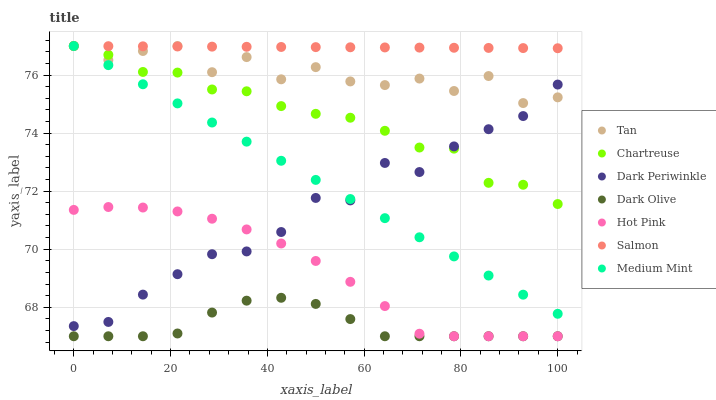Does Dark Olive have the minimum area under the curve?
Answer yes or no. Yes. Does Salmon have the maximum area under the curve?
Answer yes or no. Yes. Does Hot Pink have the minimum area under the curve?
Answer yes or no. No. Does Hot Pink have the maximum area under the curve?
Answer yes or no. No. Is Medium Mint the smoothest?
Answer yes or no. Yes. Is Tan the roughest?
Answer yes or no. Yes. Is Hot Pink the smoothest?
Answer yes or no. No. Is Hot Pink the roughest?
Answer yes or no. No. Does Hot Pink have the lowest value?
Answer yes or no. Yes. Does Salmon have the lowest value?
Answer yes or no. No. Does Tan have the highest value?
Answer yes or no. Yes. Does Hot Pink have the highest value?
Answer yes or no. No. Is Dark Olive less than Salmon?
Answer yes or no. Yes. Is Tan greater than Dark Olive?
Answer yes or no. Yes. Does Tan intersect Medium Mint?
Answer yes or no. Yes. Is Tan less than Medium Mint?
Answer yes or no. No. Is Tan greater than Medium Mint?
Answer yes or no. No. Does Dark Olive intersect Salmon?
Answer yes or no. No. 